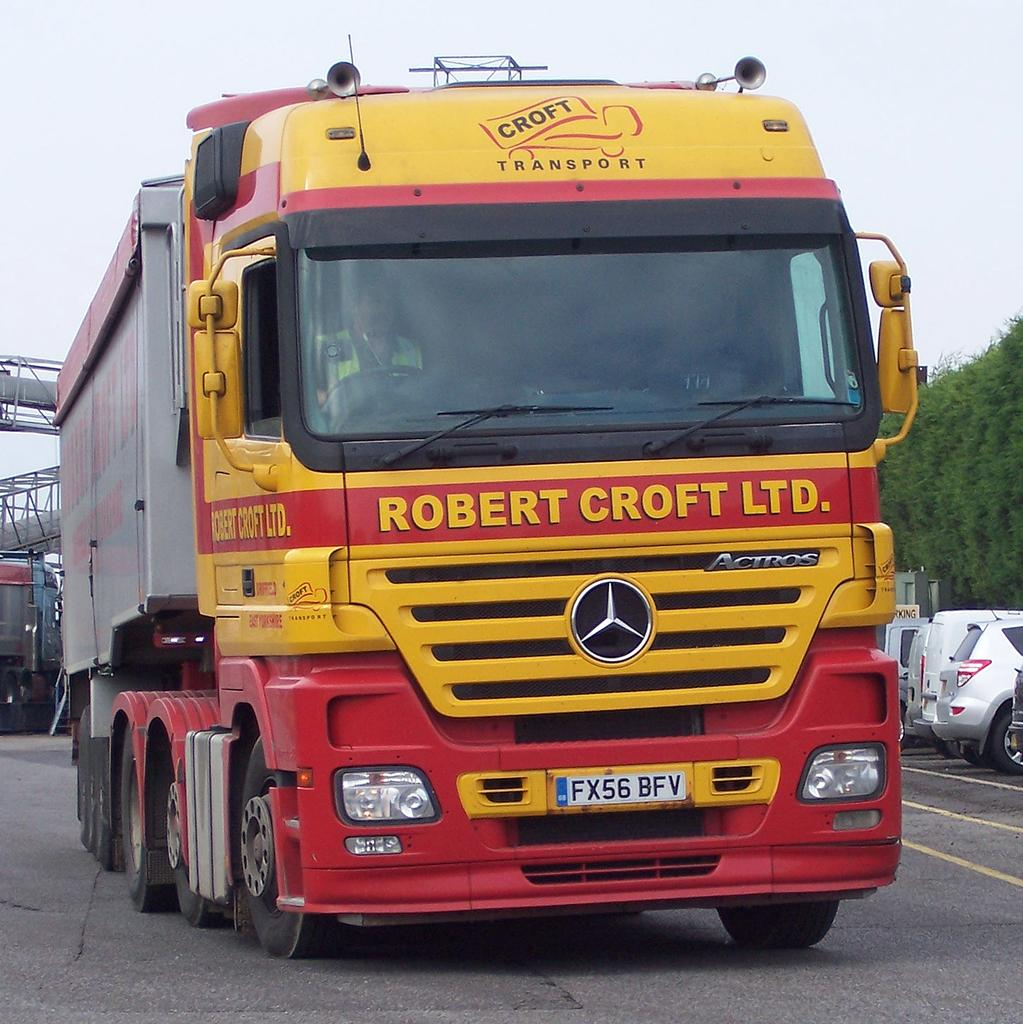What is the person in the image doing? The person in the image is driving a bus. Where is the bus located in the image? The bus is on the road. What can be seen in the background of the image? There are vehicles, trees, and some objects in the background of the image. What part of the natural environment is visible in the image? The sky is visible in the background of the image. What type of plant is being attacked by the bus in the image? There is no plant being attacked by the bus in the image; the bus is simply driving on the road. 